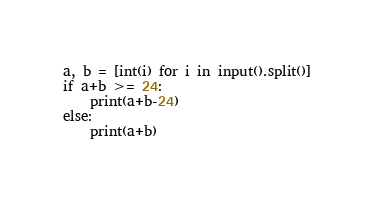Convert code to text. <code><loc_0><loc_0><loc_500><loc_500><_Python_>a, b = [int(i) for i in input().split()]
if a+b >= 24:
    print(a+b-24)
else:
    print(a+b)</code> 